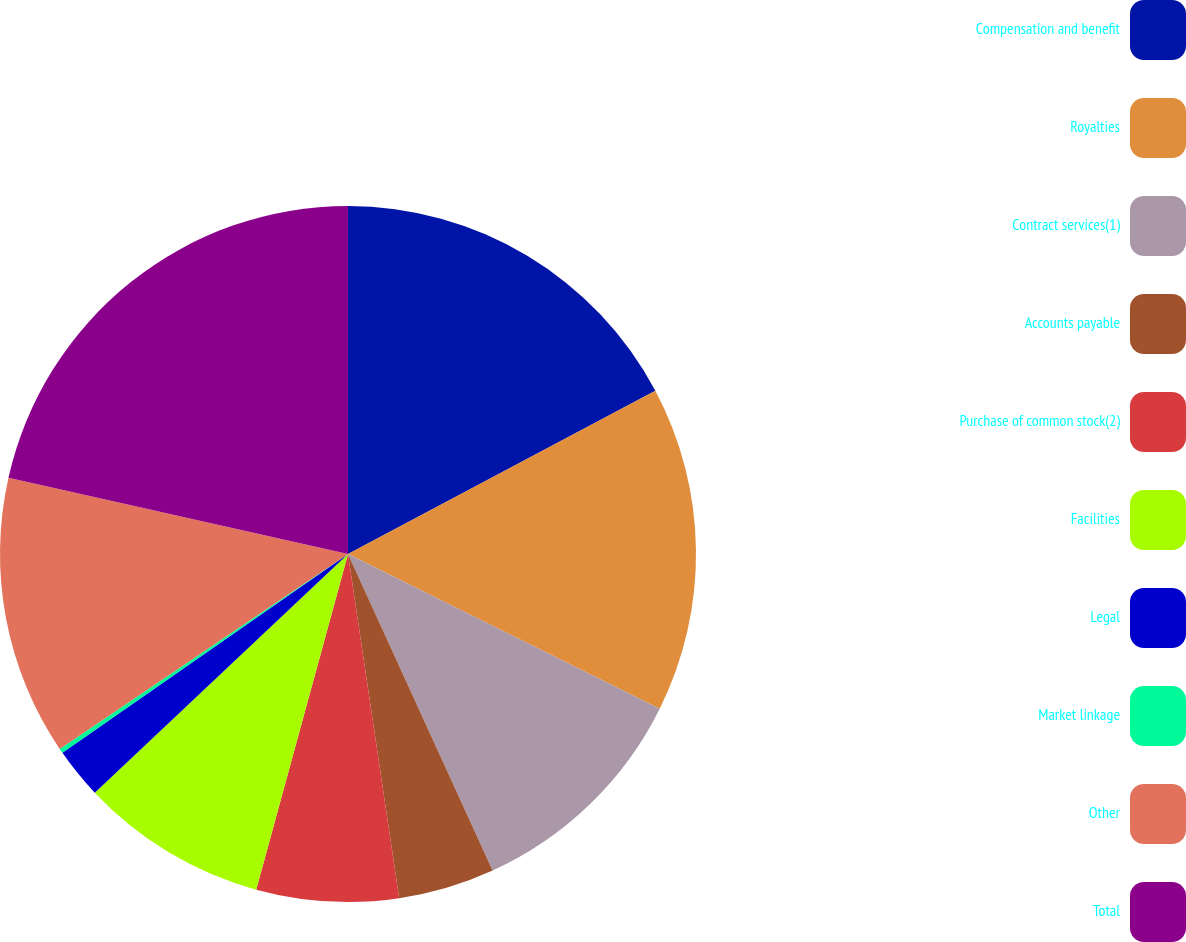Convert chart to OTSL. <chart><loc_0><loc_0><loc_500><loc_500><pie_chart><fcel>Compensation and benefit<fcel>Royalties<fcel>Contract services(1)<fcel>Accounts payable<fcel>Purchase of common stock(2)<fcel>Facilities<fcel>Legal<fcel>Market linkage<fcel>Other<fcel>Total<nl><fcel>17.23%<fcel>15.1%<fcel>10.85%<fcel>4.47%<fcel>6.6%<fcel>8.72%<fcel>2.35%<fcel>0.22%<fcel>12.98%<fcel>21.48%<nl></chart> 